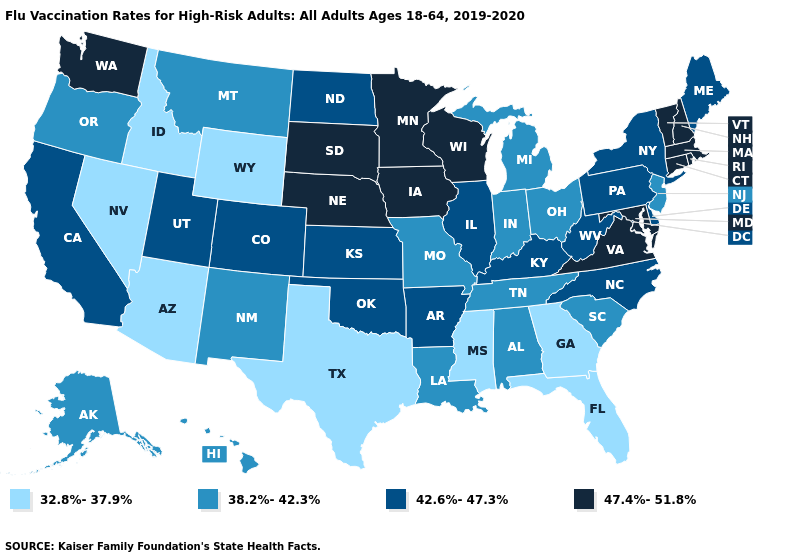Among the states that border Tennessee , which have the highest value?
Short answer required. Virginia. Does Missouri have the lowest value in the MidWest?
Concise answer only. Yes. What is the lowest value in states that border Tennessee?
Write a very short answer. 32.8%-37.9%. Among the states that border Illinois , which have the lowest value?
Short answer required. Indiana, Missouri. Name the states that have a value in the range 32.8%-37.9%?
Answer briefly. Arizona, Florida, Georgia, Idaho, Mississippi, Nevada, Texas, Wyoming. What is the value of Nevada?
Give a very brief answer. 32.8%-37.9%. What is the value of Virginia?
Keep it brief. 47.4%-51.8%. What is the lowest value in the USA?
Concise answer only. 32.8%-37.9%. What is the lowest value in the USA?
Answer briefly. 32.8%-37.9%. Does the first symbol in the legend represent the smallest category?
Be succinct. Yes. Does Texas have the lowest value in the USA?
Be succinct. Yes. Does the map have missing data?
Short answer required. No. Does Maryland have a higher value than Ohio?
Write a very short answer. Yes. Name the states that have a value in the range 47.4%-51.8%?
Give a very brief answer. Connecticut, Iowa, Maryland, Massachusetts, Minnesota, Nebraska, New Hampshire, Rhode Island, South Dakota, Vermont, Virginia, Washington, Wisconsin. What is the value of Arkansas?
Keep it brief. 42.6%-47.3%. 